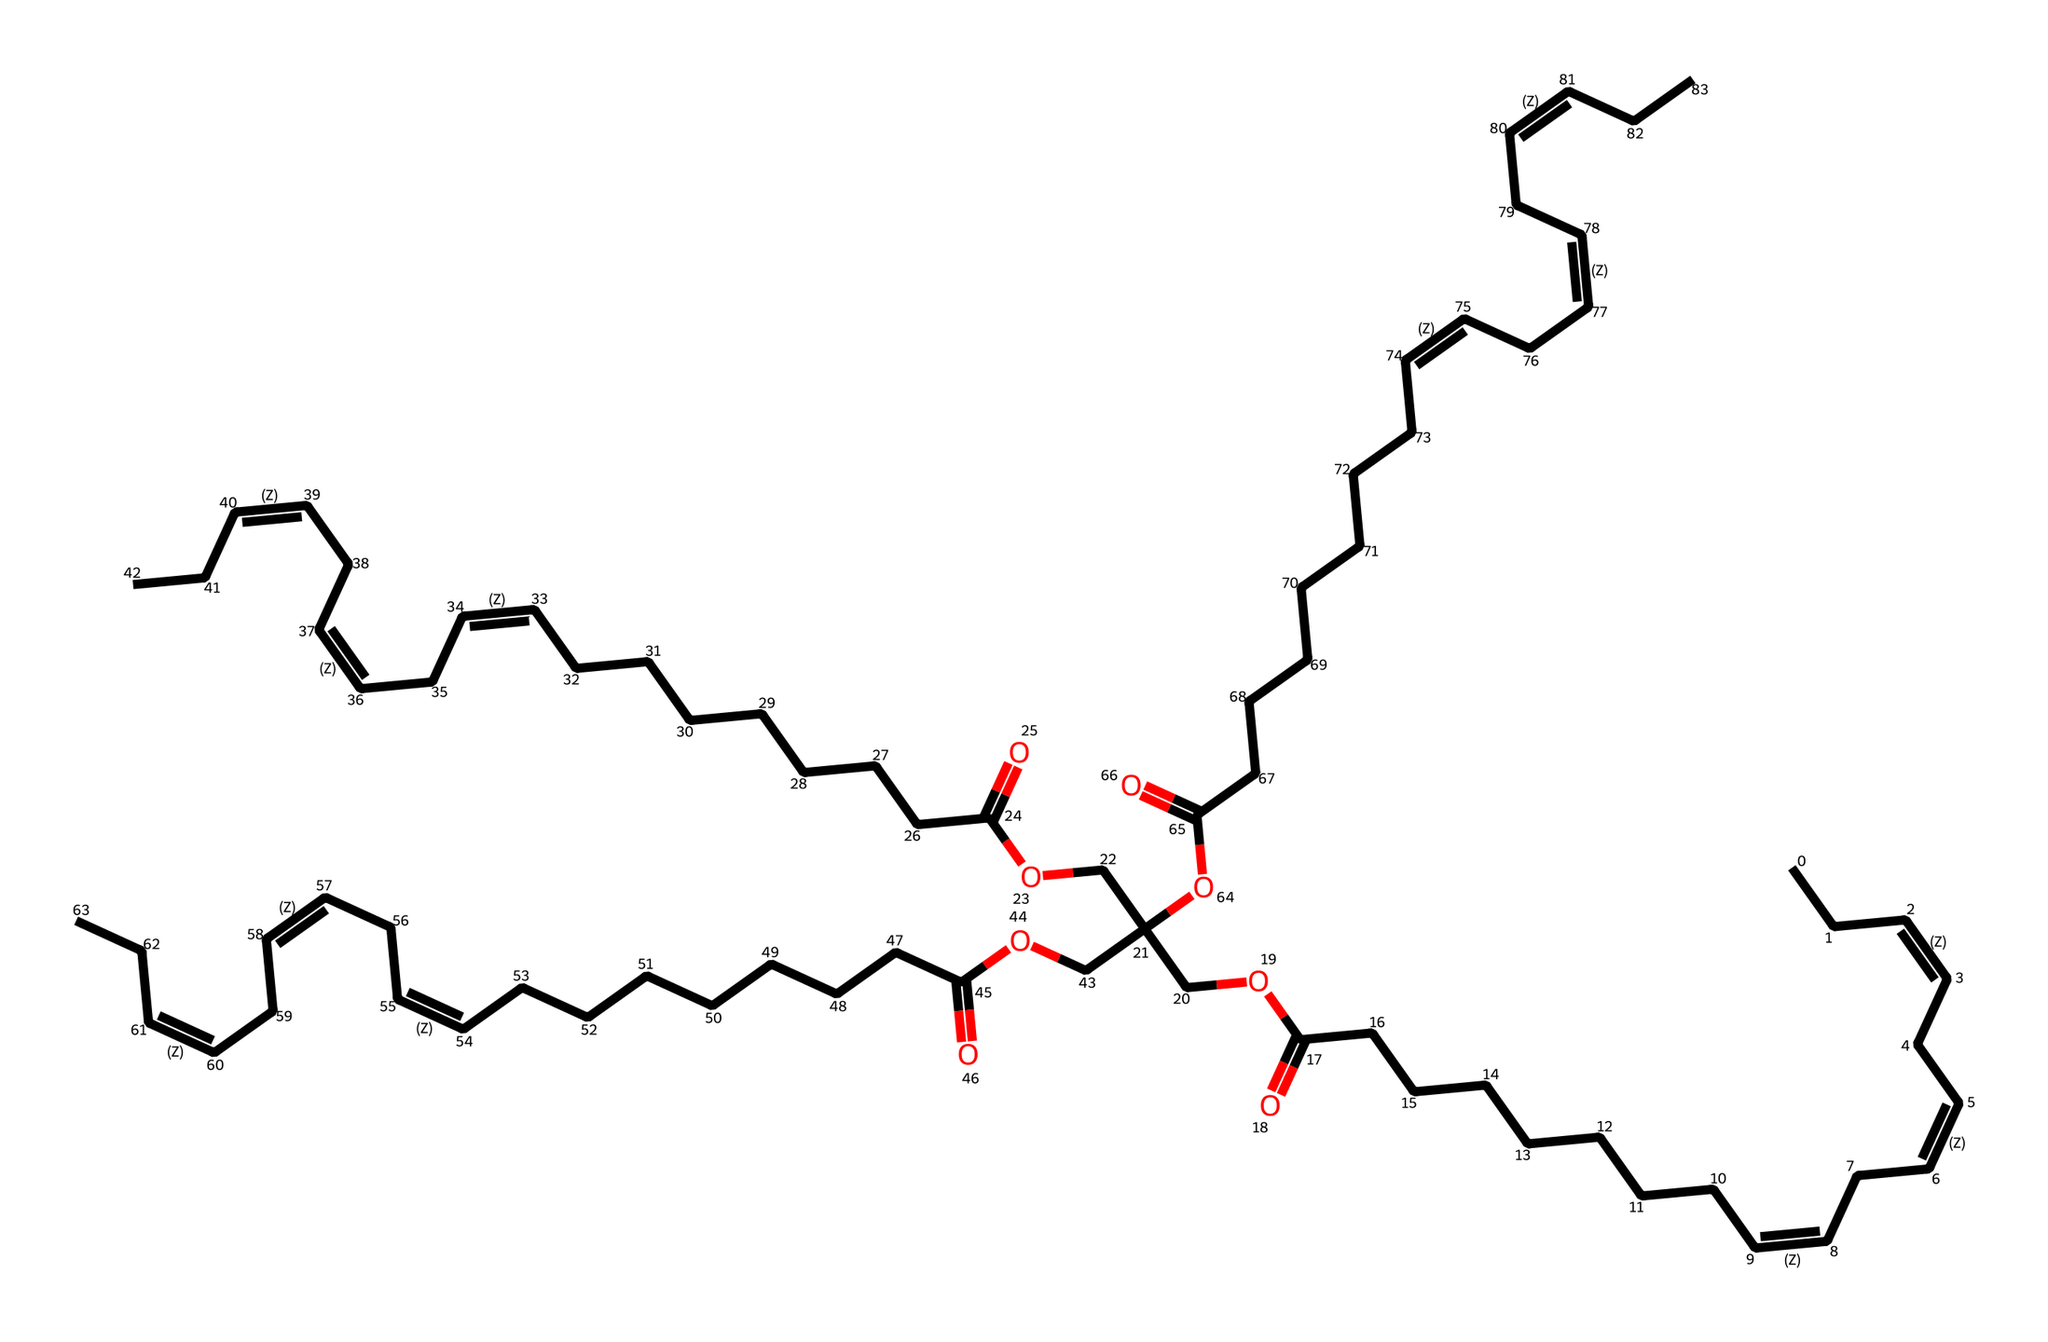how many carbon atoms are in linseed oil? By analyzing the provided SMILES representation, we can count the number of carbon (C) atoms present. Each "C" in the SMILES indicates one carbon atom. In total, the structure indicates there are 60 carbon atoms.
Answer: 60 what type of functional group is present in linseed oil? The presence of the "CCC(=O)O" fragment in the SMILES indicates the presence of a carboxylic acid functional group. This fragment specifically includes a carbonyl (C=O) and a hydroxyl (OH) group attached to the carbon chain, which confirms its identity as a carboxylic acid.
Answer: carboxylic acid what distinguishes linseed oil from other oils? Linseed oil is primarily distinguished by its high content of α-linolenic acid and other polyunsaturated fatty acids, as seen in the multiple double bonds in the carbon chain structure. This structure contributes to its drying properties, making it a traditional wood finish.
Answer: drying properties how many double bonds are present in linseed oil? By examining the SMILES notation, we can see three instances of "/C=C\" which indicates a double bond between carbons. Therefore, there are three double bonds present in the structure of linseed oil.
Answer: 3 what is the overall category of linseed oil? Linseed oil is categorized as a non-electrolyte because it does not dissociate into ions in solution and does not conduct electricity. This classification follows from its structure as a large organic molecule without ionic constituents.
Answer: non-electrolyte what is the significance of linseed oil in wood finishing? Linseed oil is significant in wood finishing due to its ability to penetrate wood fibers, enhancing the appearance while providing a protective layer against moisture. The chemical structure's fatty acid chains allow it to dry and harden, which is essential for effective wood treatment.
Answer: protective layer 